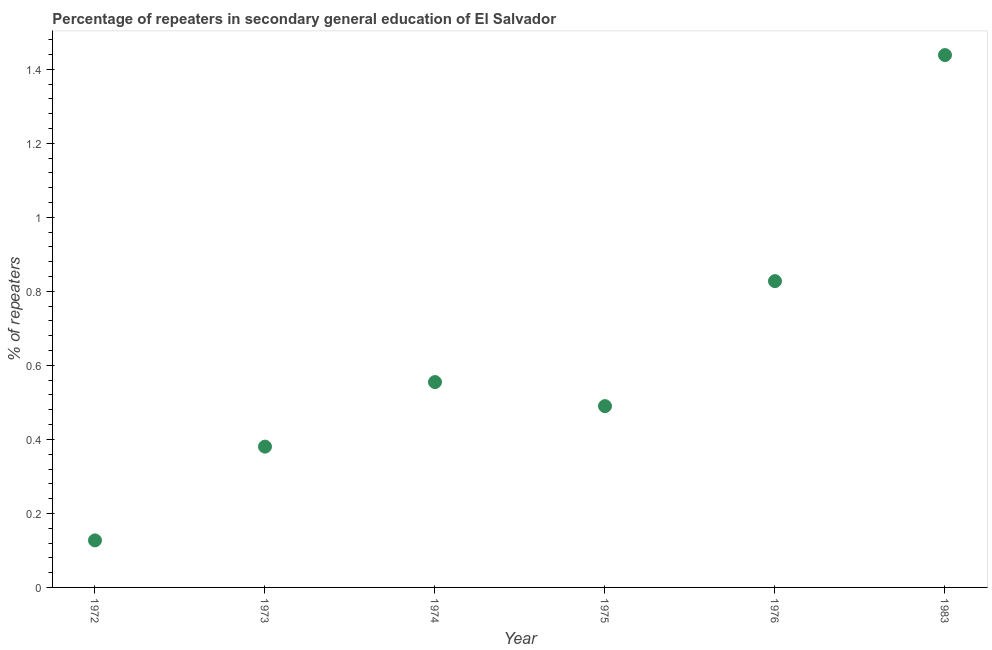What is the percentage of repeaters in 1975?
Give a very brief answer. 0.49. Across all years, what is the maximum percentage of repeaters?
Your response must be concise. 1.44. Across all years, what is the minimum percentage of repeaters?
Make the answer very short. 0.13. In which year was the percentage of repeaters maximum?
Your response must be concise. 1983. What is the sum of the percentage of repeaters?
Give a very brief answer. 3.82. What is the difference between the percentage of repeaters in 1974 and 1975?
Provide a succinct answer. 0.06. What is the average percentage of repeaters per year?
Your answer should be very brief. 0.64. What is the median percentage of repeaters?
Make the answer very short. 0.52. In how many years, is the percentage of repeaters greater than 0.28 %?
Provide a succinct answer. 5. What is the ratio of the percentage of repeaters in 1973 to that in 1976?
Your response must be concise. 0.46. Is the percentage of repeaters in 1973 less than that in 1974?
Keep it short and to the point. Yes. Is the difference between the percentage of repeaters in 1972 and 1974 greater than the difference between any two years?
Ensure brevity in your answer.  No. What is the difference between the highest and the second highest percentage of repeaters?
Provide a succinct answer. 0.61. Is the sum of the percentage of repeaters in 1973 and 1974 greater than the maximum percentage of repeaters across all years?
Provide a succinct answer. No. What is the difference between the highest and the lowest percentage of repeaters?
Your answer should be compact. 1.31. In how many years, is the percentage of repeaters greater than the average percentage of repeaters taken over all years?
Offer a terse response. 2. Does the percentage of repeaters monotonically increase over the years?
Your answer should be very brief. No. What is the difference between two consecutive major ticks on the Y-axis?
Your answer should be compact. 0.2. Are the values on the major ticks of Y-axis written in scientific E-notation?
Your response must be concise. No. Does the graph contain any zero values?
Provide a succinct answer. No. What is the title of the graph?
Provide a succinct answer. Percentage of repeaters in secondary general education of El Salvador. What is the label or title of the X-axis?
Offer a very short reply. Year. What is the label or title of the Y-axis?
Ensure brevity in your answer.  % of repeaters. What is the % of repeaters in 1972?
Provide a short and direct response. 0.13. What is the % of repeaters in 1973?
Offer a very short reply. 0.38. What is the % of repeaters in 1974?
Your response must be concise. 0.55. What is the % of repeaters in 1975?
Your answer should be compact. 0.49. What is the % of repeaters in 1976?
Offer a very short reply. 0.83. What is the % of repeaters in 1983?
Your response must be concise. 1.44. What is the difference between the % of repeaters in 1972 and 1973?
Provide a short and direct response. -0.25. What is the difference between the % of repeaters in 1972 and 1974?
Provide a succinct answer. -0.43. What is the difference between the % of repeaters in 1972 and 1975?
Provide a short and direct response. -0.36. What is the difference between the % of repeaters in 1972 and 1976?
Provide a succinct answer. -0.7. What is the difference between the % of repeaters in 1972 and 1983?
Your answer should be compact. -1.31. What is the difference between the % of repeaters in 1973 and 1974?
Your response must be concise. -0.17. What is the difference between the % of repeaters in 1973 and 1975?
Give a very brief answer. -0.11. What is the difference between the % of repeaters in 1973 and 1976?
Make the answer very short. -0.45. What is the difference between the % of repeaters in 1973 and 1983?
Provide a short and direct response. -1.06. What is the difference between the % of repeaters in 1974 and 1975?
Give a very brief answer. 0.06. What is the difference between the % of repeaters in 1974 and 1976?
Ensure brevity in your answer.  -0.27. What is the difference between the % of repeaters in 1974 and 1983?
Offer a terse response. -0.88. What is the difference between the % of repeaters in 1975 and 1976?
Your response must be concise. -0.34. What is the difference between the % of repeaters in 1975 and 1983?
Give a very brief answer. -0.95. What is the difference between the % of repeaters in 1976 and 1983?
Provide a succinct answer. -0.61. What is the ratio of the % of repeaters in 1972 to that in 1973?
Offer a terse response. 0.33. What is the ratio of the % of repeaters in 1972 to that in 1974?
Provide a short and direct response. 0.23. What is the ratio of the % of repeaters in 1972 to that in 1975?
Your answer should be compact. 0.26. What is the ratio of the % of repeaters in 1972 to that in 1976?
Your answer should be compact. 0.15. What is the ratio of the % of repeaters in 1972 to that in 1983?
Ensure brevity in your answer.  0.09. What is the ratio of the % of repeaters in 1973 to that in 1974?
Give a very brief answer. 0.69. What is the ratio of the % of repeaters in 1973 to that in 1975?
Offer a very short reply. 0.78. What is the ratio of the % of repeaters in 1973 to that in 1976?
Ensure brevity in your answer.  0.46. What is the ratio of the % of repeaters in 1973 to that in 1983?
Ensure brevity in your answer.  0.27. What is the ratio of the % of repeaters in 1974 to that in 1975?
Give a very brief answer. 1.13. What is the ratio of the % of repeaters in 1974 to that in 1976?
Offer a very short reply. 0.67. What is the ratio of the % of repeaters in 1974 to that in 1983?
Offer a very short reply. 0.39. What is the ratio of the % of repeaters in 1975 to that in 1976?
Give a very brief answer. 0.59. What is the ratio of the % of repeaters in 1975 to that in 1983?
Ensure brevity in your answer.  0.34. What is the ratio of the % of repeaters in 1976 to that in 1983?
Make the answer very short. 0.57. 